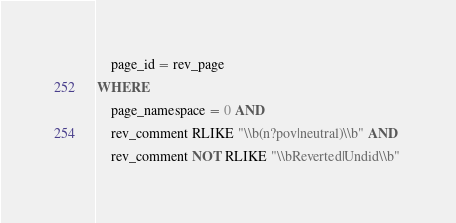<code> <loc_0><loc_0><loc_500><loc_500><_SQL_>	page_id = rev_page
WHERE
	page_namespace = 0 AND 
	rev_comment RLIKE "\\b(n?pov|neutral)\\b" AND 
	rev_comment NOT RLIKE "\\bReverted|Undid\\b"

</code> 